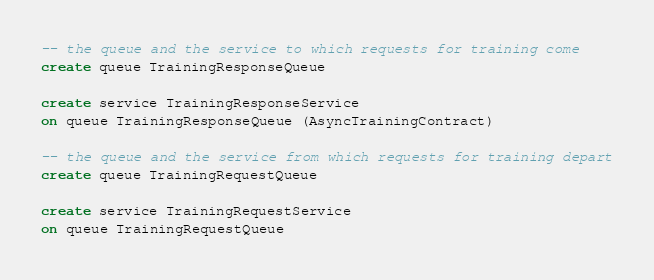<code> <loc_0><loc_0><loc_500><loc_500><_SQL_>-- the queue and the service to which requests for training come
create queue TrainingResponseQueue

create service TrainingResponseService 
on queue TrainingResponseQueue (AsyncTrainingContract)

-- the queue and the service from which requests for training depart
create queue TrainingRequestQueue

create service TrainingRequestService 
on queue TrainingRequestQueue</code> 